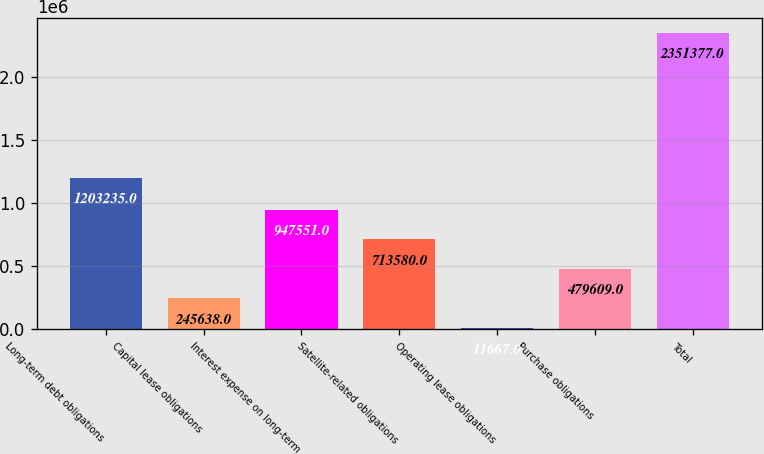<chart> <loc_0><loc_0><loc_500><loc_500><bar_chart><fcel>Long-term debt obligations<fcel>Capital lease obligations<fcel>Interest expense on long-term<fcel>Satellite-related obligations<fcel>Operating lease obligations<fcel>Purchase obligations<fcel>Total<nl><fcel>1.20324e+06<fcel>245638<fcel>947551<fcel>713580<fcel>11667<fcel>479609<fcel>2.35138e+06<nl></chart> 